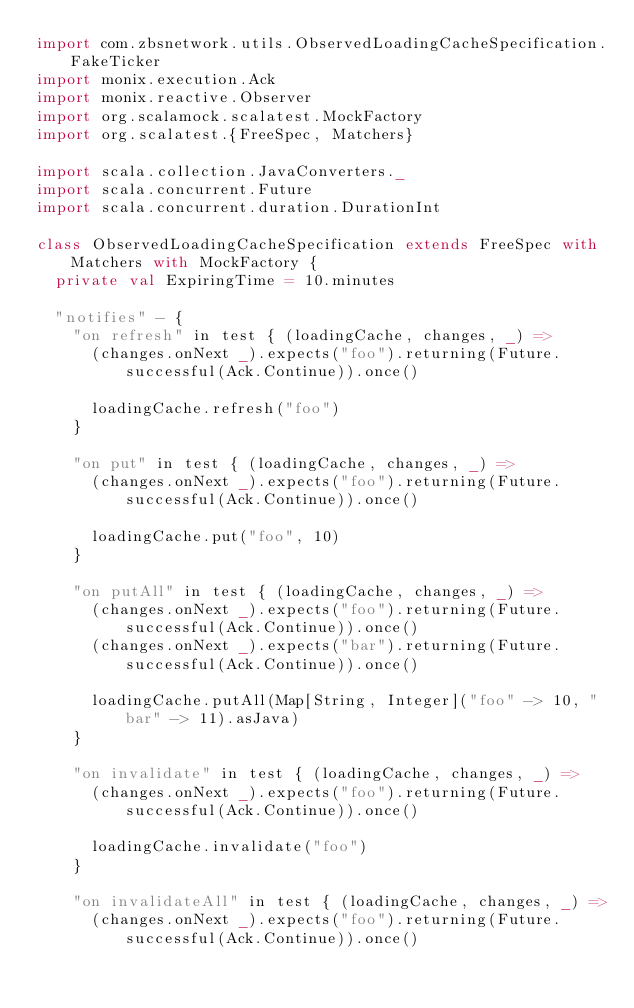Convert code to text. <code><loc_0><loc_0><loc_500><loc_500><_Scala_>import com.zbsnetwork.utils.ObservedLoadingCacheSpecification.FakeTicker
import monix.execution.Ack
import monix.reactive.Observer
import org.scalamock.scalatest.MockFactory
import org.scalatest.{FreeSpec, Matchers}

import scala.collection.JavaConverters._
import scala.concurrent.Future
import scala.concurrent.duration.DurationInt

class ObservedLoadingCacheSpecification extends FreeSpec with Matchers with MockFactory {
  private val ExpiringTime = 10.minutes

  "notifies" - {
    "on refresh" in test { (loadingCache, changes, _) =>
      (changes.onNext _).expects("foo").returning(Future.successful(Ack.Continue)).once()

      loadingCache.refresh("foo")
    }

    "on put" in test { (loadingCache, changes, _) =>
      (changes.onNext _).expects("foo").returning(Future.successful(Ack.Continue)).once()

      loadingCache.put("foo", 10)
    }

    "on putAll" in test { (loadingCache, changes, _) =>
      (changes.onNext _).expects("foo").returning(Future.successful(Ack.Continue)).once()
      (changes.onNext _).expects("bar").returning(Future.successful(Ack.Continue)).once()

      loadingCache.putAll(Map[String, Integer]("foo" -> 10, "bar" -> 11).asJava)
    }

    "on invalidate" in test { (loadingCache, changes, _) =>
      (changes.onNext _).expects("foo").returning(Future.successful(Ack.Continue)).once()

      loadingCache.invalidate("foo")
    }

    "on invalidateAll" in test { (loadingCache, changes, _) =>
      (changes.onNext _).expects("foo").returning(Future.successful(Ack.Continue)).once()</code> 